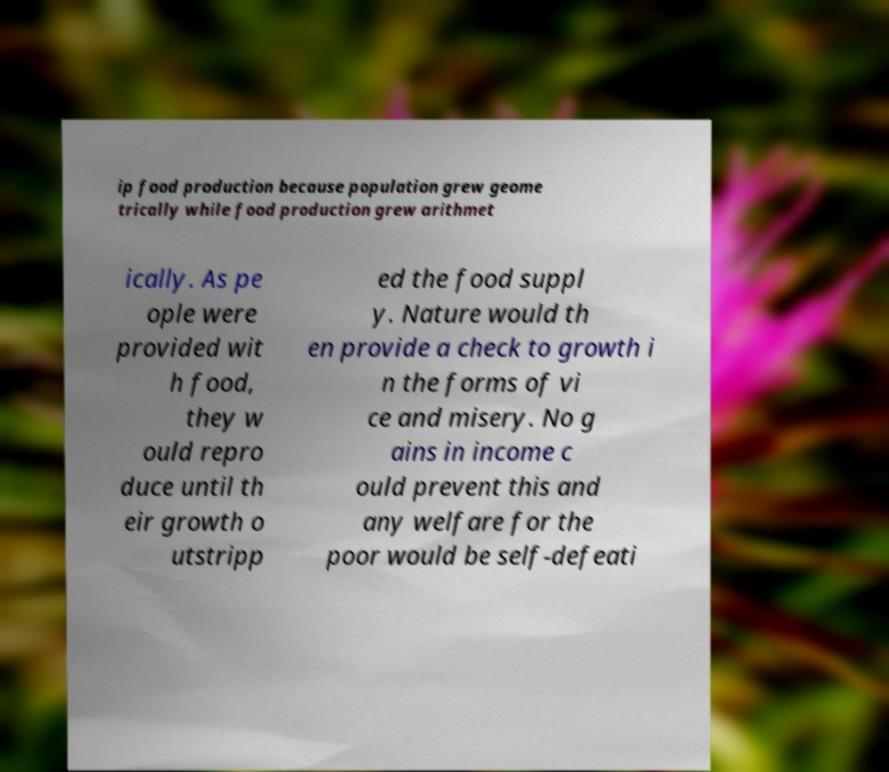Please identify and transcribe the text found in this image. ip food production because population grew geome trically while food production grew arithmet ically. As pe ople were provided wit h food, they w ould repro duce until th eir growth o utstripp ed the food suppl y. Nature would th en provide a check to growth i n the forms of vi ce and misery. No g ains in income c ould prevent this and any welfare for the poor would be self-defeati 